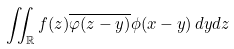Convert formula to latex. <formula><loc_0><loc_0><loc_500><loc_500>\iint _ { \mathbb { R } } f ( z ) \overline { \varphi ( z - y ) } \phi ( x - y ) \, d y d z</formula> 